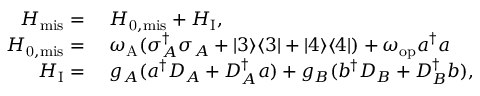Convert formula to latex. <formula><loc_0><loc_0><loc_500><loc_500>\begin{array} { r l } { H _ { m i s } = } & H _ { 0 , m i s } + H _ { I } , } \\ { H _ { 0 , m i s } = } & \omega _ { A } ( \sigma _ { A } ^ { \dagger } \sigma _ { A } + | 3 \rangle \langle 3 | + | 4 \rangle \langle 4 | ) + \omega _ { o p } a ^ { \dagger } a } \\ { H _ { I } = } & g _ { A } ( a ^ { \dagger } D _ { A } + D _ { A } ^ { \dagger } a ) + g _ { B } ( b ^ { \dagger } D _ { B } + D _ { B } ^ { \dagger } b ) , } \end{array}</formula> 